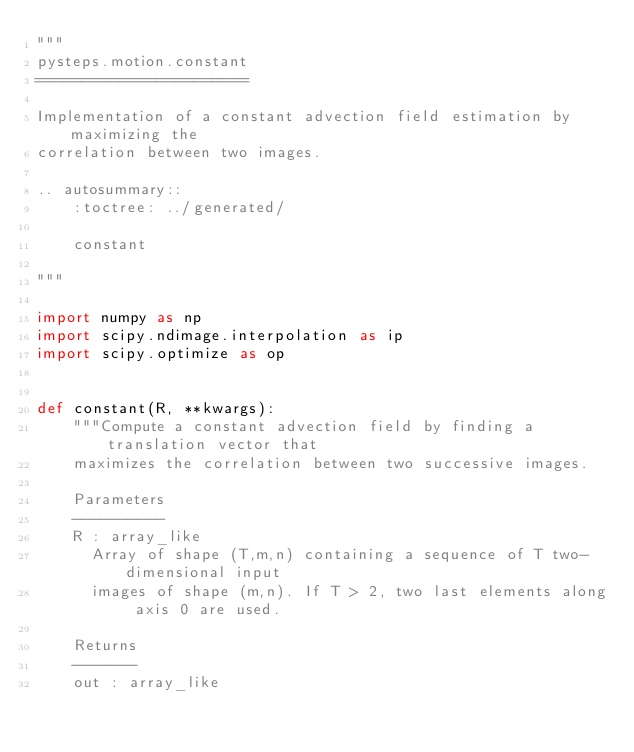<code> <loc_0><loc_0><loc_500><loc_500><_Python_>"""
pysteps.motion.constant
=======================

Implementation of a constant advection field estimation by maximizing the
correlation between two images.

.. autosummary::
    :toctree: ../generated/

    constant

"""

import numpy as np
import scipy.ndimage.interpolation as ip
import scipy.optimize as op


def constant(R, **kwargs):
    """Compute a constant advection field by finding a translation vector that
    maximizes the correlation between two successive images.

    Parameters
    ----------
    R : array_like
      Array of shape (T,m,n) containing a sequence of T two-dimensional input
      images of shape (m,n). If T > 2, two last elements along axis 0 are used.

    Returns
    -------
    out : array_like</code> 